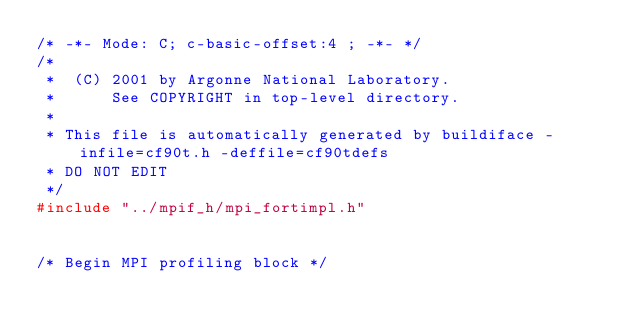Convert code to text. <code><loc_0><loc_0><loc_500><loc_500><_C_>/* -*- Mode: C; c-basic-offset:4 ; -*- */
/*  
 *  (C) 2001 by Argonne National Laboratory.
 *      See COPYRIGHT in top-level directory.
 *
 * This file is automatically generated by buildiface -infile=cf90t.h -deffile=cf90tdefs
 * DO NOT EDIT
 */
#include "../mpif_h/mpi_fortimpl.h"


/* Begin MPI profiling block */</code> 